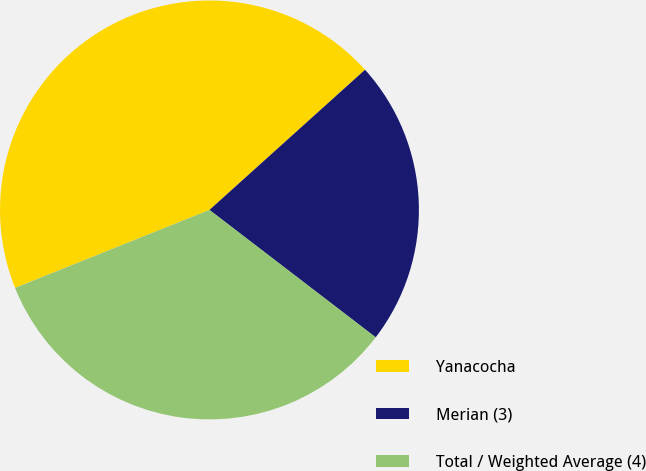Convert chart to OTSL. <chart><loc_0><loc_0><loc_500><loc_500><pie_chart><fcel>Yanacocha<fcel>Merian (3)<fcel>Total / Weighted Average (4)<nl><fcel>44.4%<fcel>22.08%<fcel>33.52%<nl></chart> 